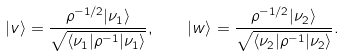Convert formula to latex. <formula><loc_0><loc_0><loc_500><loc_500>| v \rangle = \frac { \rho ^ { - 1 / 2 } | \nu _ { 1 } \rangle } { \sqrt { \langle \nu _ { 1 } | \rho ^ { - 1 } | \nu _ { 1 } \rangle } } , \quad | w \rangle = \frac { \rho ^ { - 1 / 2 } | \nu _ { 2 } \rangle } { \sqrt { \langle \nu _ { 2 } | \rho ^ { - 1 } | \nu _ { 2 } \rangle } } .</formula> 